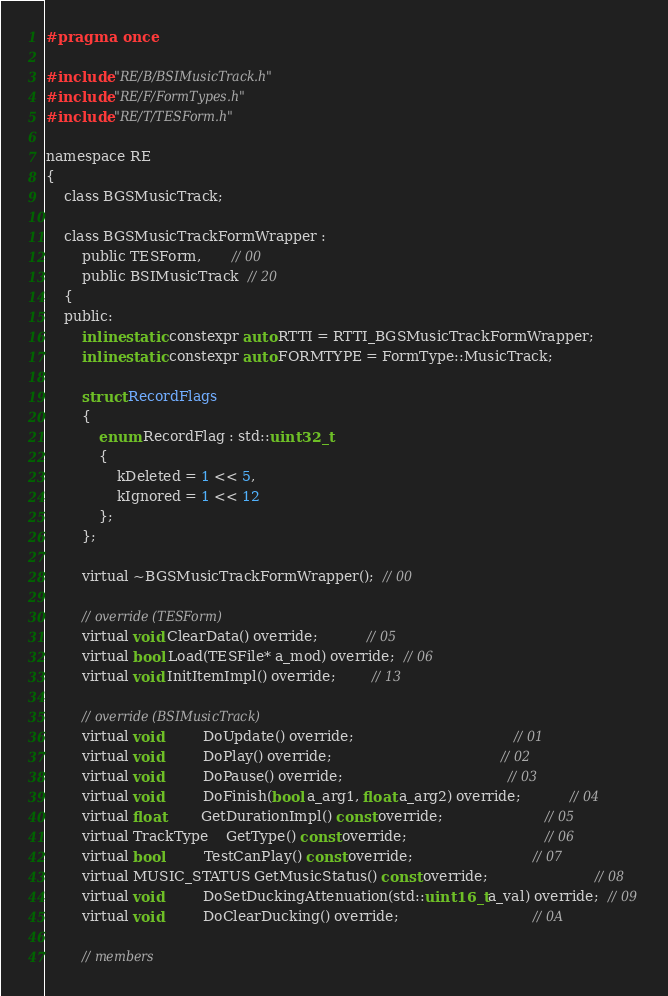Convert code to text. <code><loc_0><loc_0><loc_500><loc_500><_C_>#pragma once

#include "RE/B/BSIMusicTrack.h"
#include "RE/F/FormTypes.h"
#include "RE/T/TESForm.h"

namespace RE
{
	class BGSMusicTrack;

	class BGSMusicTrackFormWrapper :
		public TESForm,       // 00
		public BSIMusicTrack  // 20
	{
	public:
		inline static constexpr auto RTTI = RTTI_BGSMusicTrackFormWrapper;
		inline static constexpr auto FORMTYPE = FormType::MusicTrack;

		struct RecordFlags
		{
			enum RecordFlag : std::uint32_t
			{
				kDeleted = 1 << 5,
				kIgnored = 1 << 12
			};
		};

		virtual ~BGSMusicTrackFormWrapper();  // 00

		// override (TESForm)
		virtual void ClearData() override;           // 05
		virtual bool Load(TESFile* a_mod) override;  // 06
		virtual void InitItemImpl() override;        // 13

		// override (BSIMusicTrack)
		virtual void         DoUpdate() override;                                    // 01
		virtual void         DoPlay() override;                                      // 02
		virtual void         DoPause() override;                                     // 03
		virtual void         DoFinish(bool a_arg1, float a_arg2) override;           // 04
		virtual float        GetDurationImpl() const override;                       // 05
		virtual TrackType    GetType() const override;                               // 06
		virtual bool         TestCanPlay() const override;                           // 07
		virtual MUSIC_STATUS GetMusicStatus() const override;                        // 08
		virtual void         DoSetDuckingAttenuation(std::uint16_t a_val) override;  // 09
		virtual void         DoClearDucking() override;                              // 0A

		// members</code> 